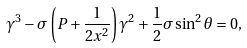<formula> <loc_0><loc_0><loc_500><loc_500>\gamma ^ { 3 } - \sigma \left ( P + \frac { 1 } { 2 x ^ { 2 } } \right ) \gamma ^ { 2 } + \frac { 1 } { 2 } \sigma \sin ^ { 2 } \theta = 0 ,</formula> 